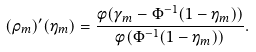Convert formula to latex. <formula><loc_0><loc_0><loc_500><loc_500>( \rho _ { m } ) ^ { \prime } ( \eta _ { m } ) = \frac { \phi ( \gamma _ { m } - \Phi ^ { - 1 } ( 1 - \eta _ { m } ) ) } { \phi ( \Phi ^ { - 1 } ( 1 - \eta _ { m } ) ) } .</formula> 